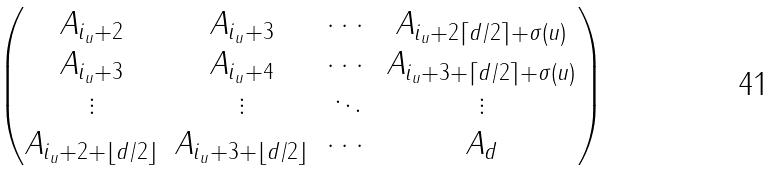<formula> <loc_0><loc_0><loc_500><loc_500>\begin{pmatrix} A _ { i _ { u } + 2 } & A _ { i _ { u } + 3 } & \cdots & A _ { i _ { u } + 2 \lceil d / 2 \rceil + \sigma ( u ) } \\ A _ { i _ { u } + 3 } & A _ { i _ { u } + 4 } & \cdots & A _ { i _ { u } + 3 + \lceil d / 2 \rceil + \sigma ( u ) } \\ \vdots & \vdots & \ddots & \vdots \\ A _ { i _ { u } + 2 + \lfloor d / 2 \rfloor } & A _ { i _ { u } + 3 + \lfloor d / 2 \rfloor } & \cdots & A _ { d } \end{pmatrix}</formula> 